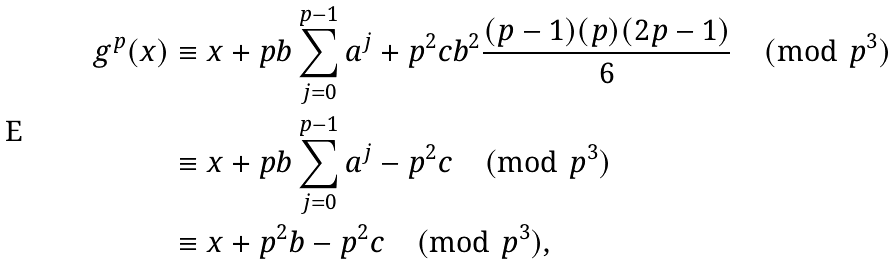<formula> <loc_0><loc_0><loc_500><loc_500>g ^ { p } ( x ) & \equiv x + p b \sum _ { j = 0 } ^ { p - 1 } a ^ { j } + p ^ { 2 } c b ^ { 2 } \frac { ( p - 1 ) ( p ) ( 2 p - 1 ) } { 6 } \pmod { p ^ { 3 } } \\ & \equiv x + p b \sum _ { j = 0 } ^ { p - 1 } a ^ { j } - p ^ { 2 } c \pmod { p ^ { 3 } } \\ & \equiv x + p ^ { 2 } b - p ^ { 2 } c \pmod { p ^ { 3 } } ,</formula> 